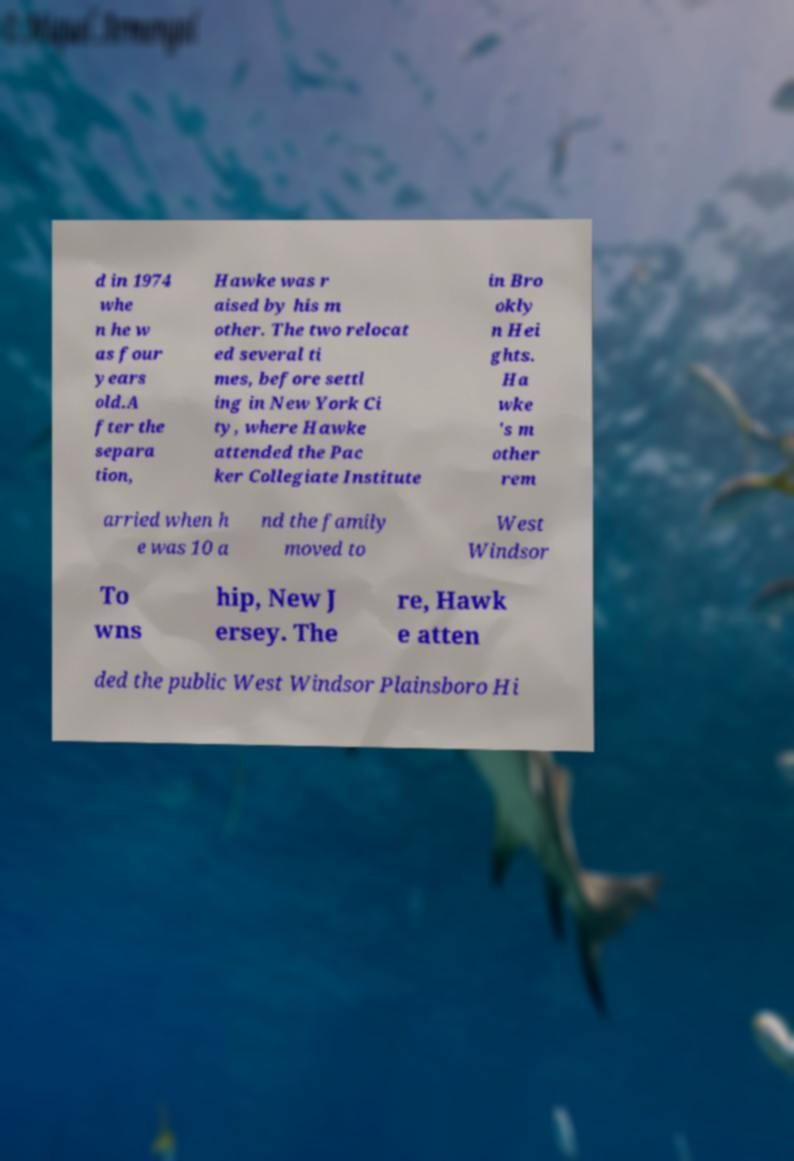Could you assist in decoding the text presented in this image and type it out clearly? d in 1974 whe n he w as four years old.A fter the separa tion, Hawke was r aised by his m other. The two relocat ed several ti mes, before settl ing in New York Ci ty, where Hawke attended the Pac ker Collegiate Institute in Bro okly n Hei ghts. Ha wke 's m other rem arried when h e was 10 a nd the family moved to West Windsor To wns hip, New J ersey. The re, Hawk e atten ded the public West Windsor Plainsboro Hi 